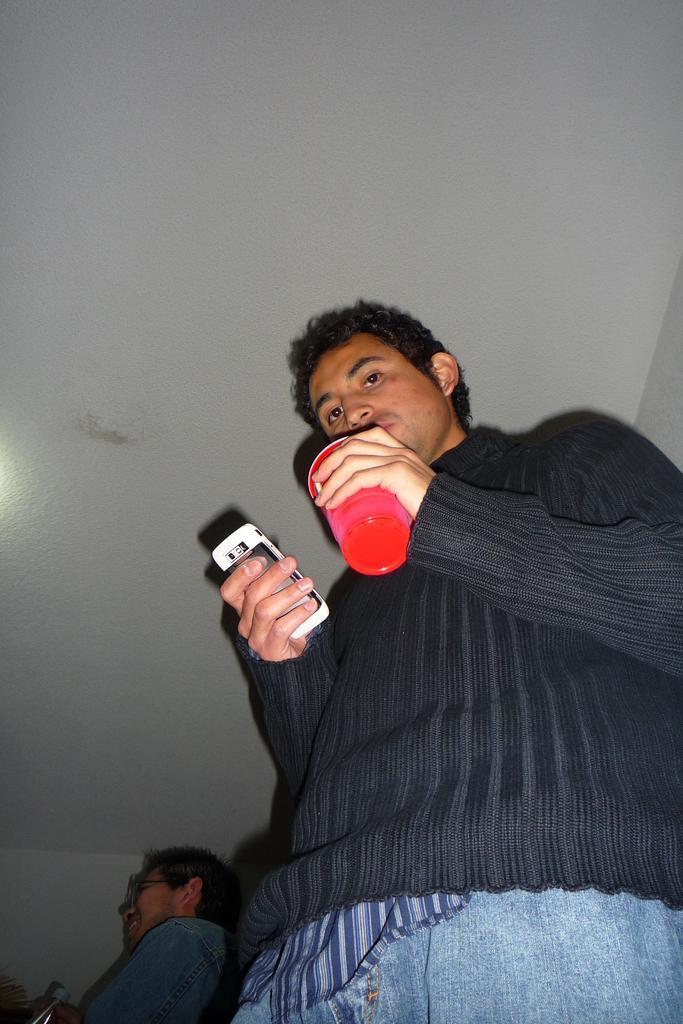Can you describe this image briefly? A person in black dress is holding a bottle and a mobile. Behind him there is an another guy. And above him there is a ceiling. 